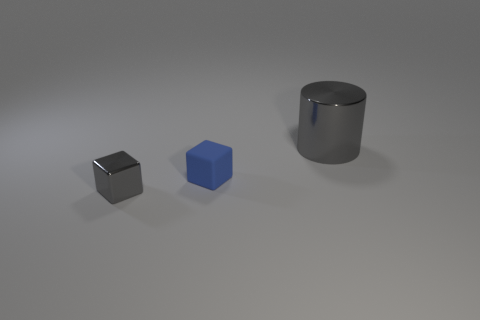What number of things are small things that are on the right side of the small metallic block or big cylinders?
Provide a short and direct response. 2. What is the material of the large cylinder?
Your answer should be compact. Metal. Do the metallic block and the cylinder have the same size?
Offer a very short reply. No. What number of spheres are tiny blue rubber objects or blue metallic things?
Offer a very short reply. 0. There is a small thing right of the gray object that is on the left side of the large thing; what is its color?
Ensure brevity in your answer.  Blue. Is the number of small cubes that are on the left side of the blue rubber cube less than the number of cylinders behind the big metal cylinder?
Make the answer very short. No. Does the rubber cube have the same size as the gray thing that is behind the tiny shiny block?
Your answer should be compact. No. There is a thing that is both behind the small gray metal object and in front of the large object; what shape is it?
Your answer should be very brief. Cube. What is the size of the cube that is the same material as the cylinder?
Provide a short and direct response. Small. What number of tiny gray metallic blocks are behind the gray shiny object that is behind the tiny gray object?
Make the answer very short. 0. 